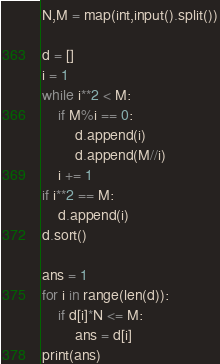Convert code to text. <code><loc_0><loc_0><loc_500><loc_500><_Python_>N,M = map(int,input().split())

d = []
i = 1
while i**2 < M:
    if M%i == 0:
        d.append(i)
        d.append(M//i)
    i += 1
if i**2 == M:
    d.append(i)
d.sort()

ans = 1
for i in range(len(d)):
    if d[i]*N <= M:
        ans = d[i]
print(ans)</code> 